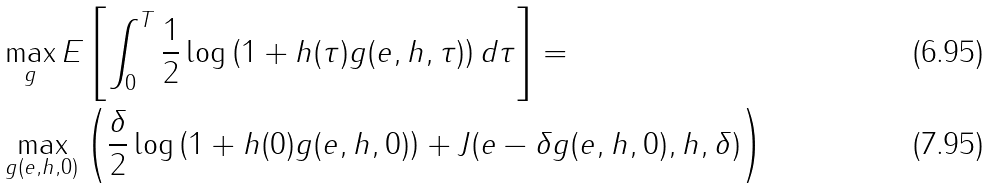<formula> <loc_0><loc_0><loc_500><loc_500>& \max _ { g } E \left [ \int _ { 0 } ^ { T } \frac { 1 } { 2 } \log \left ( 1 + h ( \tau ) g ( e , h , \tau ) \right ) d \tau \right ] = \\ & \max _ { g ( e , h , 0 ) } \left ( \frac { \delta } { 2 } \log \left ( 1 + h ( 0 ) g ( e , h , 0 ) \right ) + J ( e - \delta g ( e , h , 0 ) , h , \delta ) \right )</formula> 